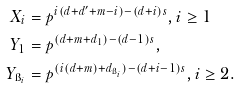Convert formula to latex. <formula><loc_0><loc_0><loc_500><loc_500>X _ { i } & = p ^ { i ( d + d ^ { \prime } + m - i ) - ( d + i ) s } , i \geq 1 \\ Y _ { 1 } & = p ^ { ( d + m + d _ { 1 } ) - ( d - 1 ) s } , \\ Y _ { \i _ { i } } & = p ^ { ( i ( d + m ) + d _ { \i _ { i } } ) - ( d + i - 1 ) s } , i \geq 2 .</formula> 